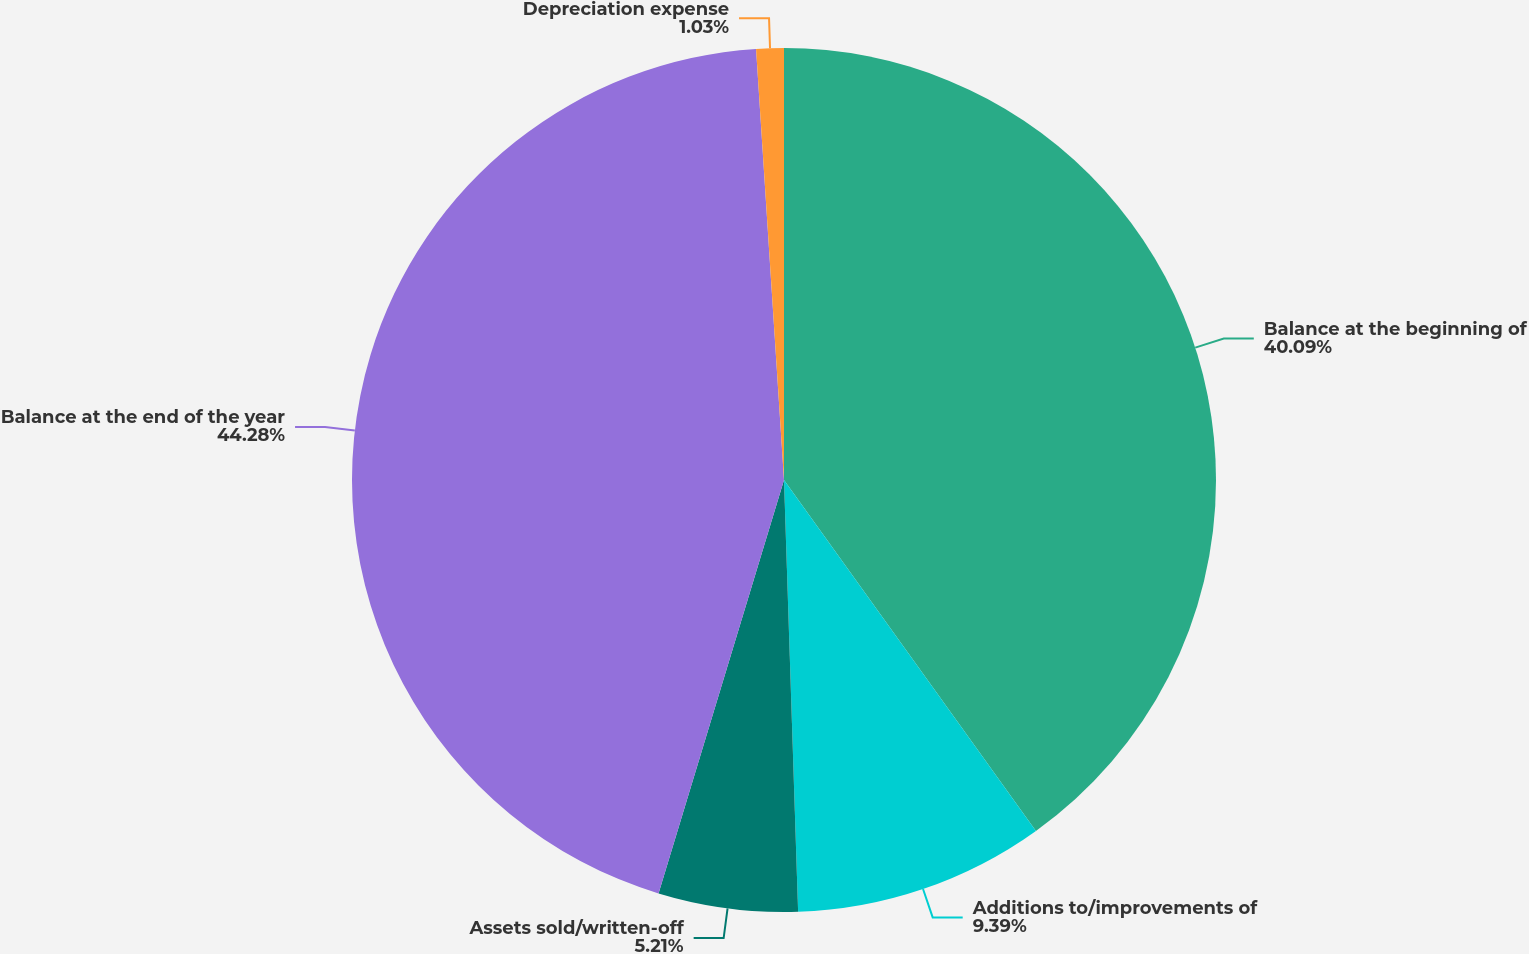Convert chart. <chart><loc_0><loc_0><loc_500><loc_500><pie_chart><fcel>Balance at the beginning of<fcel>Additions to/improvements of<fcel>Assets sold/written-off<fcel>Balance at the end of the year<fcel>Depreciation expense<nl><fcel>40.09%<fcel>9.39%<fcel>5.21%<fcel>44.28%<fcel>1.03%<nl></chart> 